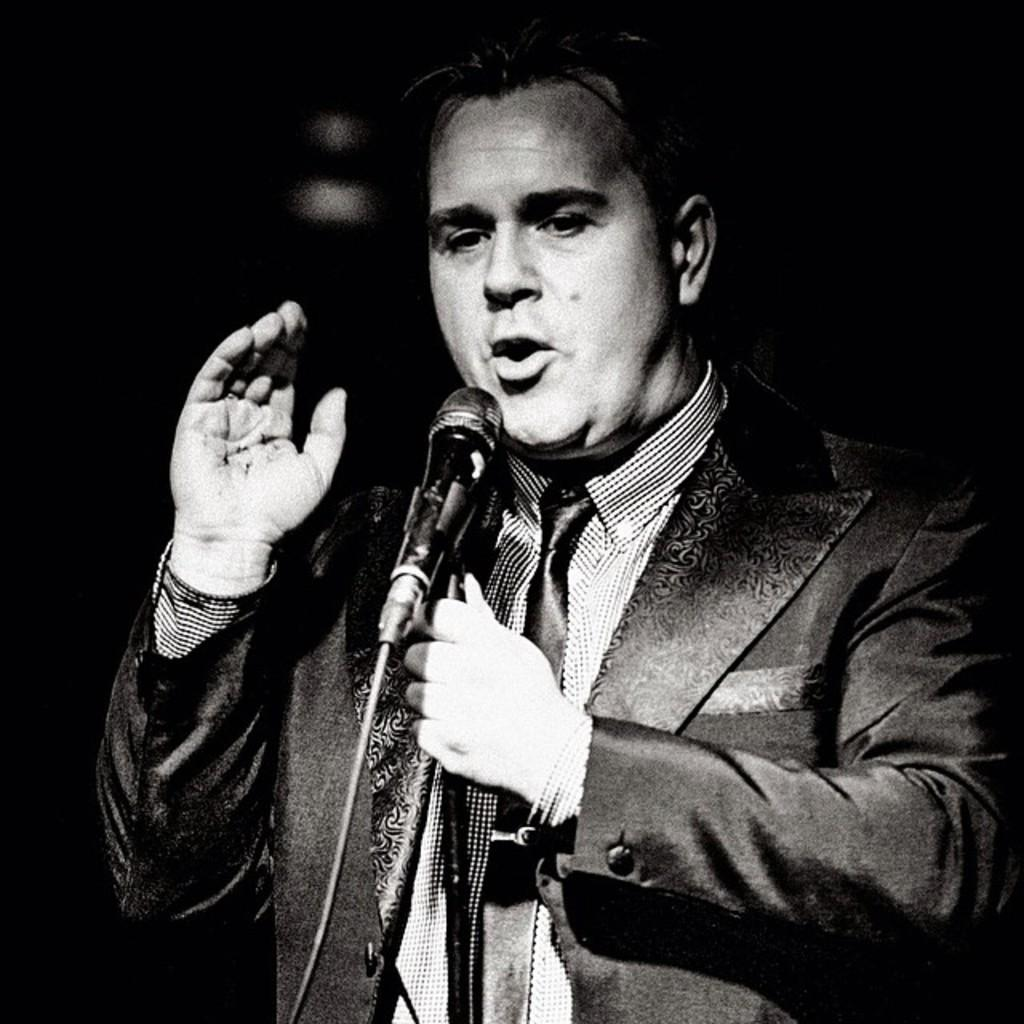What is the color scheme of the image? The image is black and white. What is the man in the image doing? The man in the image is talking into a microphone. What is the man wearing in the image? The man in the image is wearing a coat and a shirt. What can be seen in the background of the image? The background of the image is black. What type of sweater is the man wearing in the image? There is no mention of a sweater in the image. The man is wearing a coat and a shirt, as stated in the facts. 